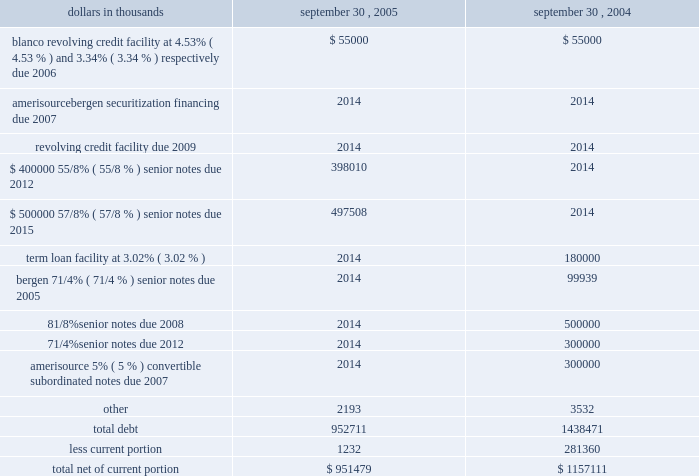Amerisourcebergen corporation 2005 during the fiscal year september 30 , 2005 , the company recorded an impairment charge of $ 5.3 million relating to certain intangible assets within its technology operations .
Amortization expense for other intangible assets was $ 10.3 million , $ 10.0 million and $ 7.0 million in the fiscal years ended september 30 , 2005 , 2004 and 2003 , respectively .
Amortization expense for other intangible assets is estimated to be $ 10.1 million in fiscal 2006 , $ 8.8 million in fiscal 2007 , $ 5.0 million in fiscal 2008 , $ 3.3 million in fiscal 2009 , $ 3.2 million in fiscal 2010 , and $ 15.9 million thereafter .
Note 6 .
Debt debt consisted of the following: .
Long-term debt in september 2005 , the company issued $ 400 million of 5.625% ( 5.625 % ) senior notes due september 15 , 2012 ( the 201c2012 notes 201d ) and $ 500 million of 5.875% ( 5.875 % ) senior notes due september 15 , 2015 ( the 201c2015 notes 201d ) .
The 2012 notes and 2015 notes each were sold at 99.5% ( 99.5 % ) of principal amount and have an effective interest yield of 5.71% ( 5.71 % ) and 5.94% ( 5.94 % ) , respectively .
Interest on the 2012 notes and the 2015 notes is payable semiannually in arrears , commencing on march 15 , 2006 .
Both the 2012 notes and the 2015 notes are redeemable at the company 2019s option at a price equal to the greater of 100% ( 100 % ) of the principal amount thereof , or the sum of the discounted value of the remaining scheduled payments , as defined .
In addition , at any time before september 15 , 2008 , the company may redeem up to an aggregate of 35% ( 35 % ) of the principal amount of the 2012 notes or the 2015 notes at redemption prices equal to 105.625% ( 105.625 % ) and 105.875% ( 105.875 % ) , respectively , of the principal amounts thereof , plus accrued and unpaid interest and liquidated damages , if any , to the date of redemption , with the cash proceeds of one or more equity issuances .
In connection with the issuance of the 2012 notes and the 2015 notes , the company incurred approximately $ 6.3 million and $ 7.9 million of costs , respectively , which were deferred and are being amortized over the terms of the notes .
The gross proceeds from the sale of the 2012 notes and the 2015 notes were used to finance the early retirement of the $ 500 million of 81 20448% ( 20448 % ) senior notes due 2008 and $ 300 million of 71 20444% ( 20444 % ) senior notes due 2012 in september 2005 , including the payment of $ 102.3 million of premiums and other costs .
Additionally , the company expensed $ 8.5 million of deferred financing costs related to the retirement of the 71 20444% ( 20444 % ) notes and the 81 20448% ( 20448 % ) notes .
In december 2004 , the company entered into a $ 700 million five-year senior unsecured revolving credit facility ( the 201csenior revolving credit facility 201d ) with a syndicate of lenders .
The senior revolving credit facility replaced the senior credit agreement , as defined below .
There were no borrowings outstanding under the senior revolving credit facility at september 30 , 2005 .
Interest on borrowings under the senior revolving credit facility accrues at specific rates based on the company 2019s debt rating .
In april 2005 , the company 2019s debt rating was raised by one of the rating agencies and in accordance with the terms of the senior revolving credit facility , interest on borrow- ings accrue at either 80 basis points over libor or the prime rate at september 30 , 2005 .
Availability under the senior revolving credit facility is reduced by the amount of outstanding letters of credit ( $ 12.0 million at september 30 , 2005 ) .
The company pays quarterly facility fees to maintain the availability under the senior revolving credit facility at specific rates based on the company 2019s debt rating .
In april 2005 , the rate payable to maintain the availability of the $ 700 million commitment was reduced to 20 basis points per annum resulting from the company 2019s improved debt rating .
In connection with entering into the senior revolving credit facility , the company incurred approximately $ 2.5 million of costs , which were deferred and are being amortized over the life of the facility .
The company may choose to repay or reduce its commitments under the senior revolving credit facility at any time .
The senior revolving credit facility contains covenants that impose limitations on , among other things , additional indebtedness , distributions and dividends to stockholders , and invest- ments .
Additional covenants require compliance with financial tests , including leverage and minimum earnings to fixed charges ratios .
In august 2001 , the company had entered into a senior secured credit agreement ( the 201csenior credit agreement 201d ) with a syndicate of lenders .
The senior credit agreement consisted of a $ 1.0 billion revolving credit facility ( the 201crevolving facility 201d ) and a $ 300 million term loan facility ( the 201cterm facility 201d ) , both of which had been scheduled to mature in august 2006 .
The term facility had scheduled quarterly maturities , which began in december 2002 , totaling $ 60 million in each of fiscal 2003 and 2004 , $ 80 million in fiscal 2005 and $ 100 million in fiscal 2006 .
The company previously paid the scheduled quarterly maturities of $ 60 million in fiscal 2004 and 2003. .
What was the change in total debt in thousands between 2004 and 2005? 
Computations: (952711 - 1438471)
Answer: -485760.0. 